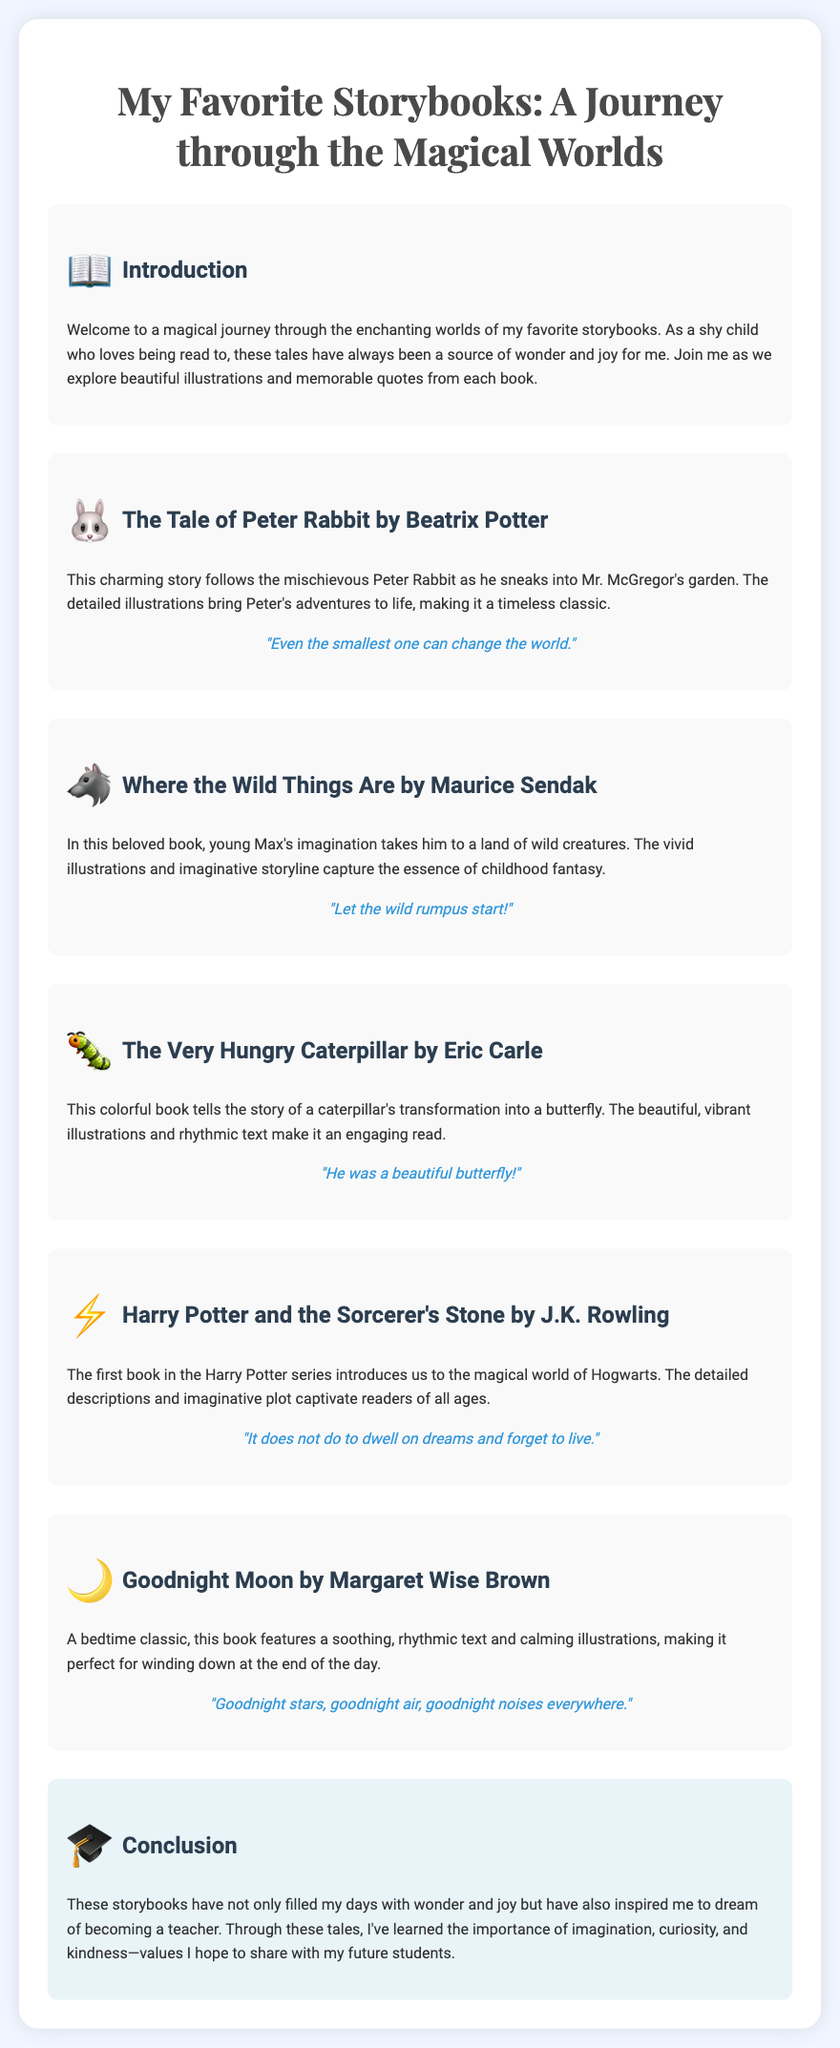What is the title of the presentation? The title of the presentation is mentioned at the top of the document.
Answer: My Favorite Storybooks: A Journey through the Magical Worlds Who is the author of "The Tale of Peter Rabbit"? The author of the book is specified in the section about it.
Answer: Beatrix Potter What animal is the main character in "Where the Wild Things Are"? The main character is identified in the title of the book.
Answer: Wild Things What does Peter Rabbit sneak into? The document describes the main plot of the story in the respective section.
Answer: Mr. McGregor's garden What is the quote from "Harry Potter and the Sorcerer's Stone"? The document provides a specific quote related to this book.
Answer: "It does not do to dwell on dreams and forget to live." What recurring theme is highlighted in the conclusion? The conclusion discusses the overall message derived from the storybooks.
Answer: Imagination, curiosity, and kindness How many storybooks are featured in the presentation? Counting the sections gives the total number of storybooks mentioned in the document.
Answer: Five What is the genre of "Goodnight Moon"? The document categorizes this book in a specific way in its description.
Answer: Bedtime story What type of illustrations are mentioned in the book about the caterpillar? The text describes the visual aspects of "The Very Hungry Caterpillar."
Answer: Vibrant illustrations 